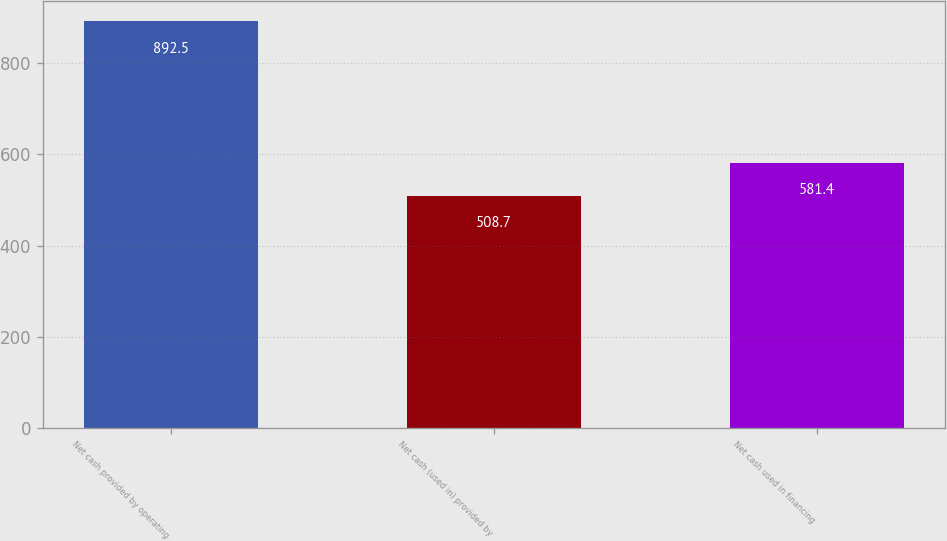Convert chart. <chart><loc_0><loc_0><loc_500><loc_500><bar_chart><fcel>Net cash provided by operating<fcel>Net cash (used in) provided by<fcel>Net cash used in financing<nl><fcel>892.5<fcel>508.7<fcel>581.4<nl></chart> 